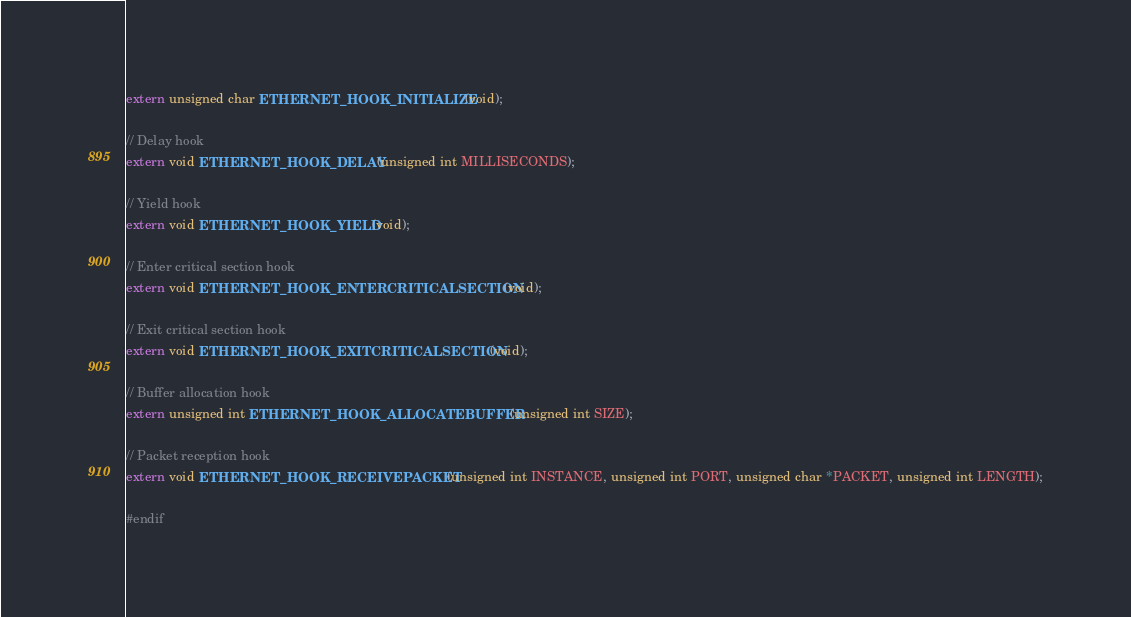Convert code to text. <code><loc_0><loc_0><loc_500><loc_500><_C_>extern unsigned char ETHERNET_HOOK_INITIALIZE(void);

// Delay hook
extern void ETHERNET_HOOK_DELAY(unsigned int MILLISECONDS);

// Yield hook
extern void ETHERNET_HOOK_YIELD(void);

// Enter critical section hook
extern void ETHERNET_HOOK_ENTERCRITICALSECTION(void);

// Exit critical section hook
extern void ETHERNET_HOOK_EXITCRITICALSECTION(void);

// Buffer allocation hook
extern unsigned int ETHERNET_HOOK_ALLOCATEBUFFER(unsigned int SIZE);

// Packet reception hook
extern void ETHERNET_HOOK_RECEIVEPACKET(unsigned int INSTANCE, unsigned int PORT, unsigned char *PACKET, unsigned int LENGTH);

#endif
</code> 